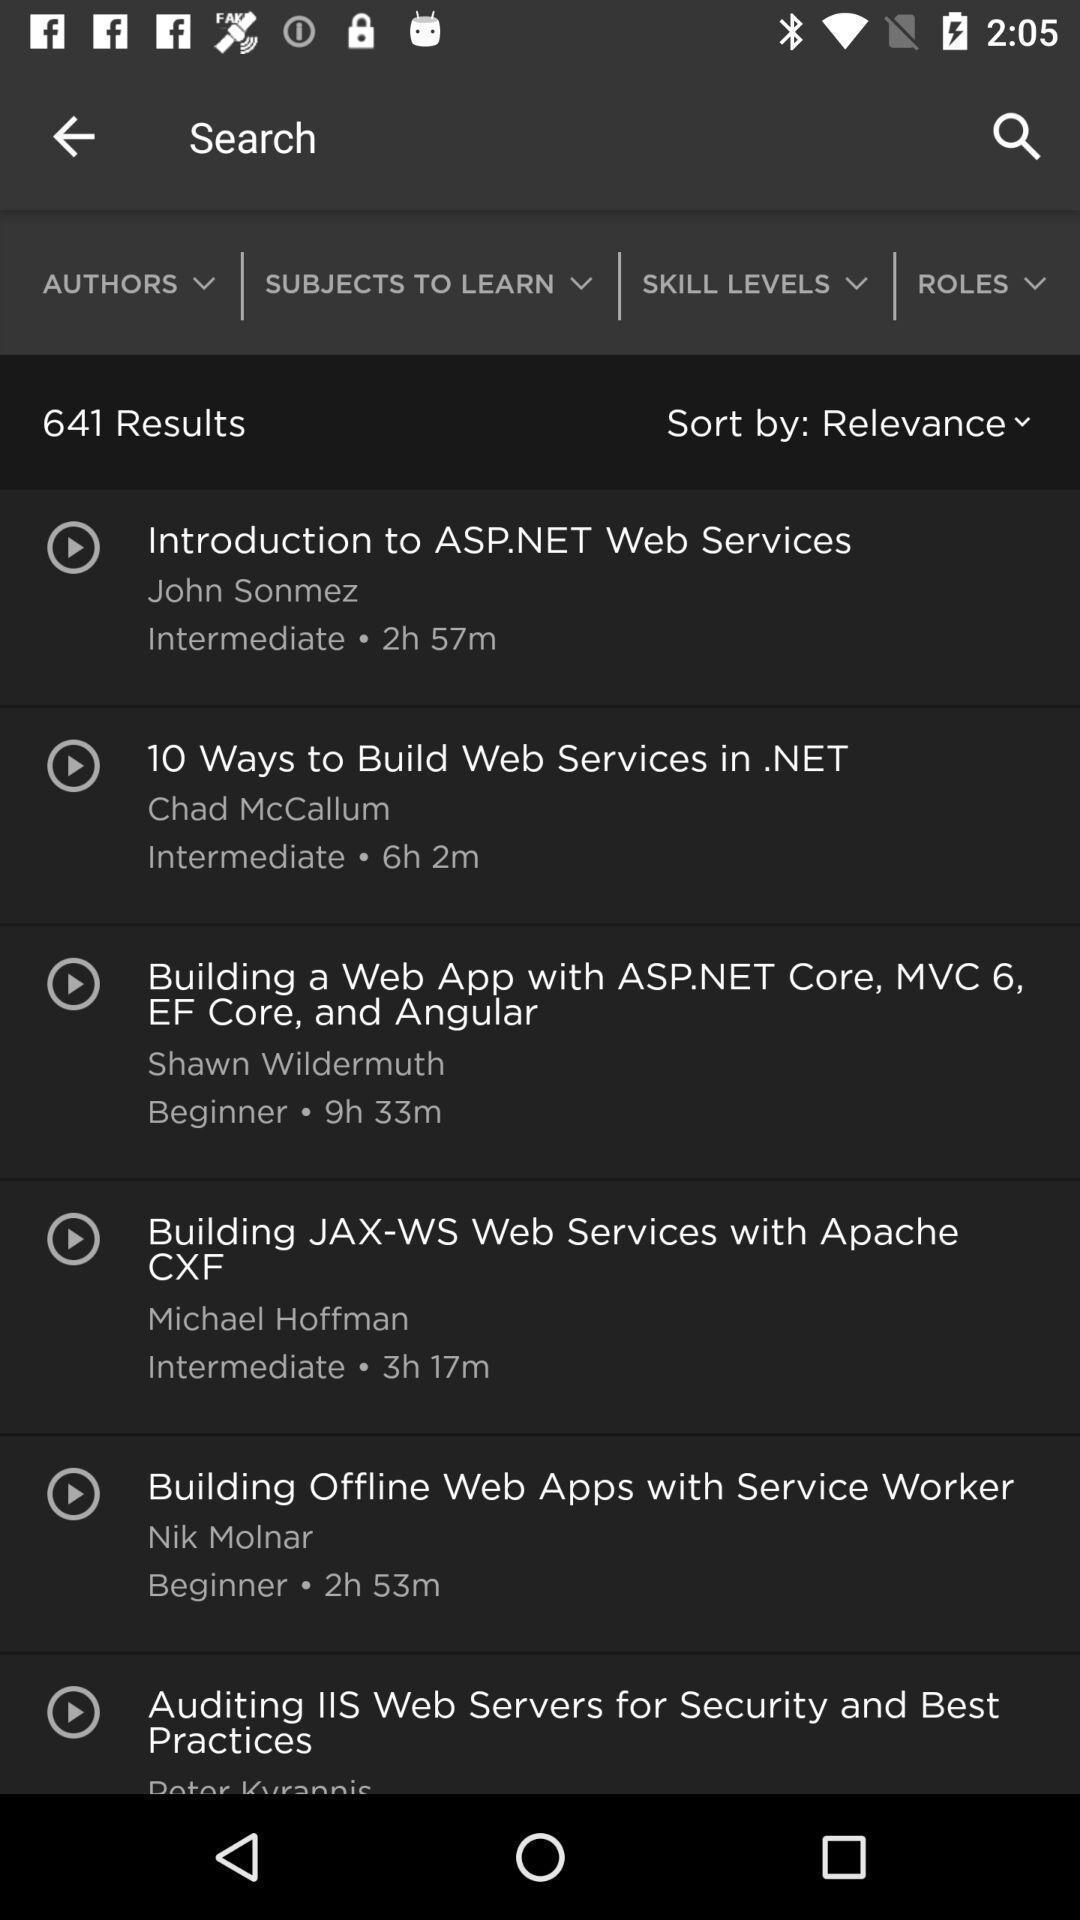Describe this image in words. Search bar to search for the videos of web services. 